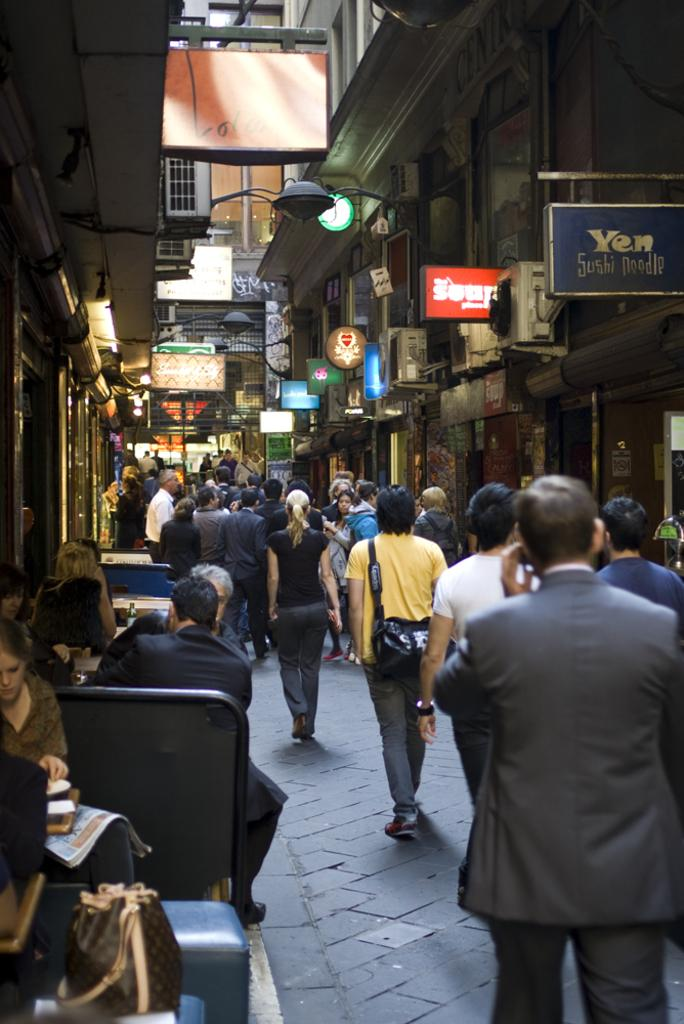What are the people in the image doing? Some people are standing on the ground, while others are sitting on chairs in the image. What can be seen in the background of the image? There are buildings visible in the background of the image. How many pigs are sitting on the chairs in the image? There are no pigs present in the image; only people are visible. What act are the people performing in the image? The image does not depict a specific act or performance; it simply shows people standing and sitting. 